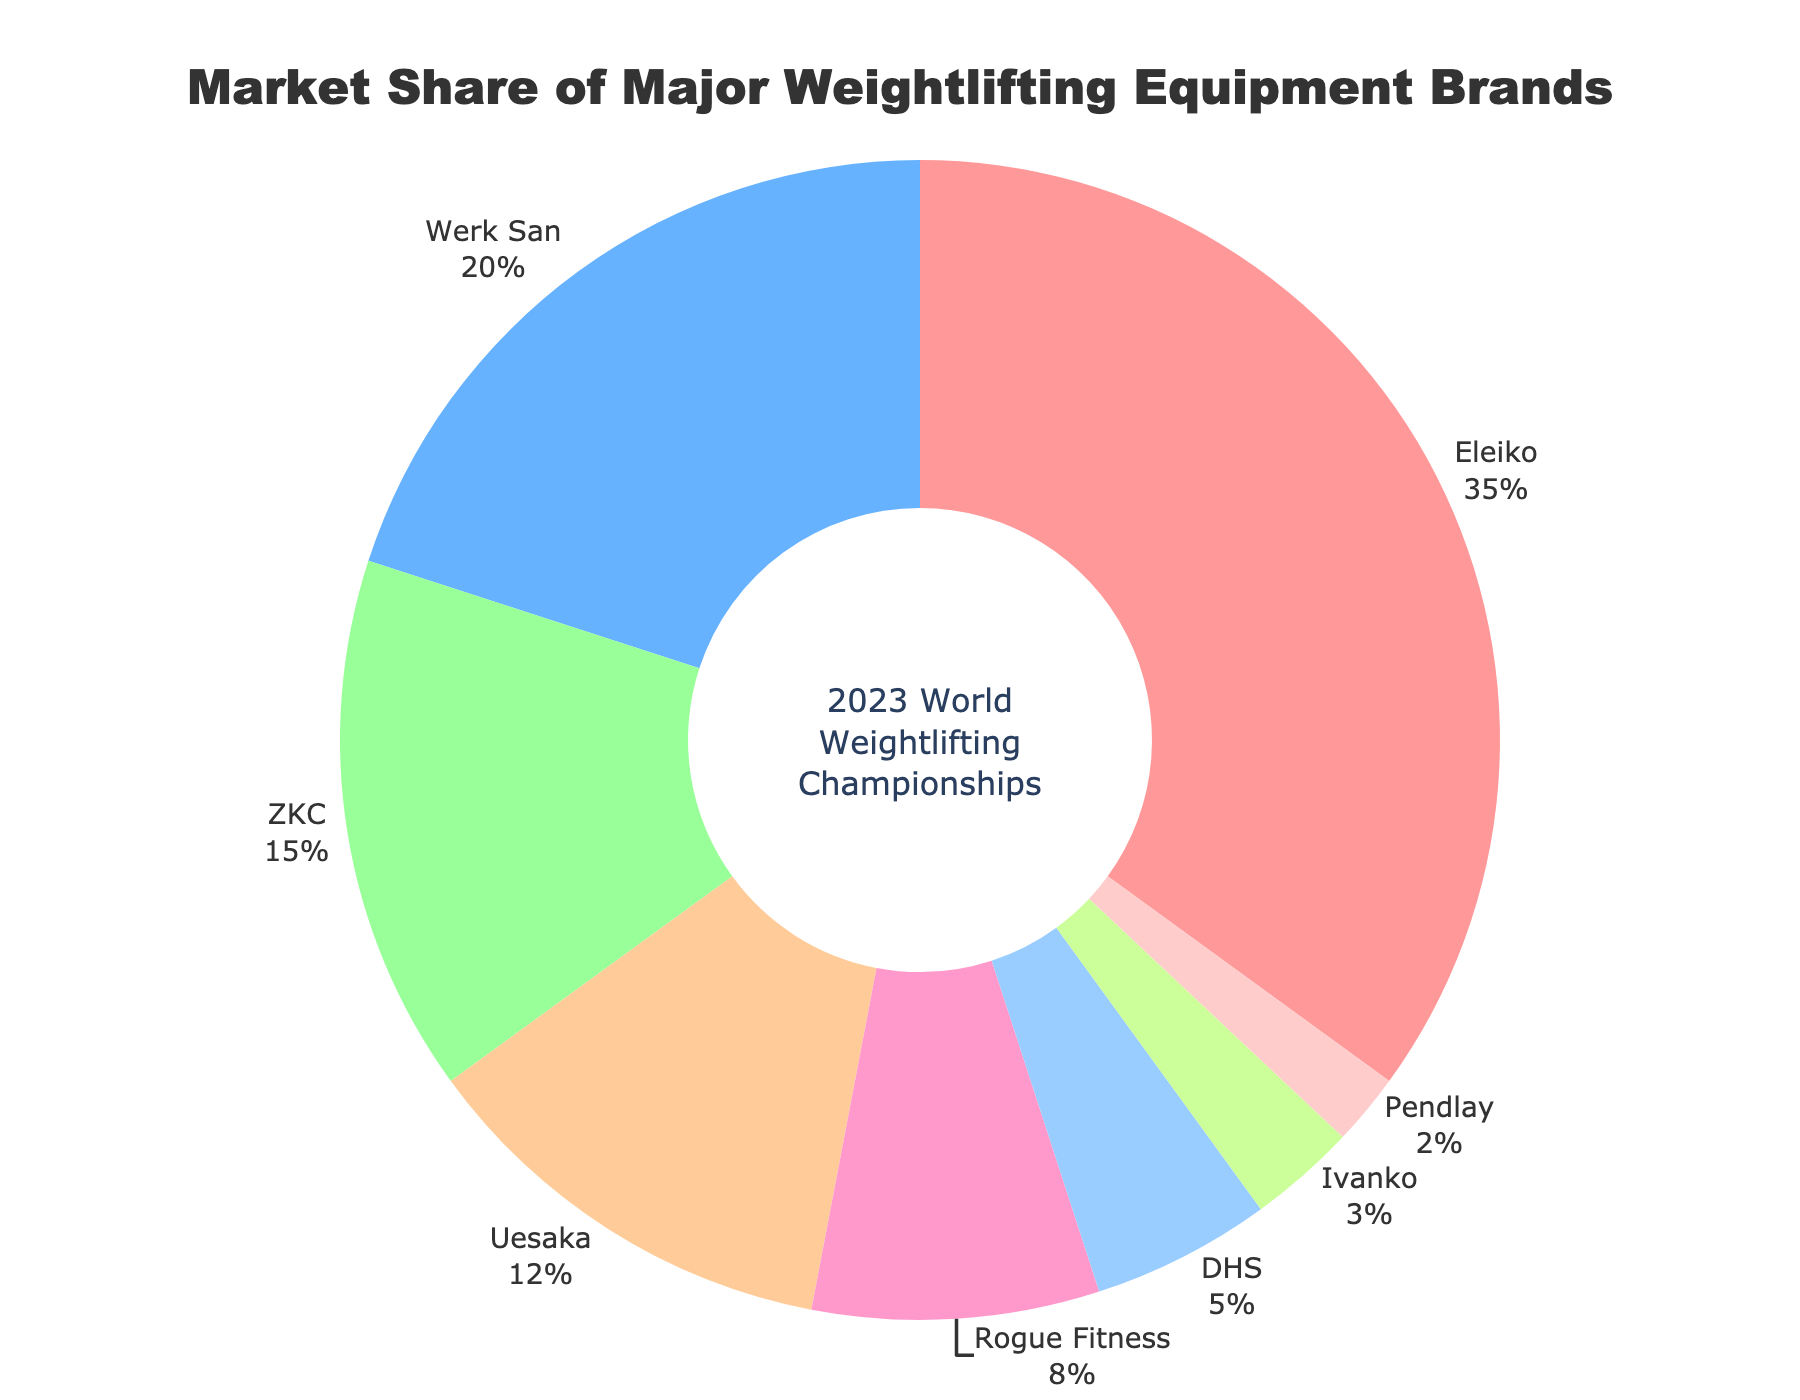Which brand has the highest market share? The brand with the largest segment in the donut chart corresponds to the highest market share, which is labeled as Eleiko with a market share of 35%.
Answer: Eleiko What is the total market share of ZKC and Uesaka combined? The market share of ZKC is 15%, and Uesaka is 12%. Summing these up, 15% + 12% = 27%.
Answer: 27% How much higher is Eleiko's market share compared to Rogue Fitness? Eleiko has a market share of 35%, while Rogue Fitness has 8%. The difference is 35% - 8% = 27%.
Answer: 27% Which three brands have the smallest market share, and what is their combined market share? The brands with the smallest market shares are Pendlay with 2%, Ivanko with 3%, and DHS with 5%. Their combined market share is 2% + 3% + 5% = 10%.
Answer: Pendlay, Ivanko, DHS, 10% Is the market share of Werk San greater than that of ZKC and Uesaka combined? Werk San has a 20% market share. ZKC and Uesaka combined have a market share of 27% (15% + 12%). 20% is less than 27%.
Answer: No Which segment is represented by the color red? Segments in the chart are distinguished by unique colors. The red segment corresponds to Eleiko as labeled in the figure.
Answer: Eleiko What is the difference in market share between DHS and Uesaka? The market share of DHS is 5%, and Uesaka is 12%. The difference is 12% - 5% = 7%.
Answer: 7% What percentage of the market is not covered by Eleiko, Werk San, and ZKC combined? Eleiko's share is 35%, Werk San's share is 20%, and ZKC's share is 15%. Their combined market share is 35% + 20% + 15% = 70%. The remaining market share is 100% - 70% = 30%.
Answer: 30% Which brand has the closest market share to half of Eleiko's market share? Eleiko's market share is 35%. Half of that is 17.5%. The closest brand to 17.5% is ZKC with 15%.
Answer: ZKC 